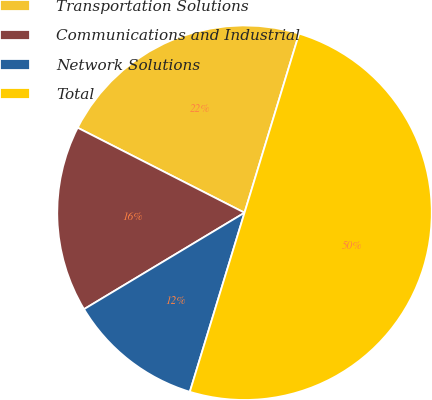<chart> <loc_0><loc_0><loc_500><loc_500><pie_chart><fcel>Transportation Solutions<fcel>Communications and Industrial<fcel>Network Solutions<fcel>Total<nl><fcel>22.21%<fcel>16.11%<fcel>11.67%<fcel>50.0%<nl></chart> 